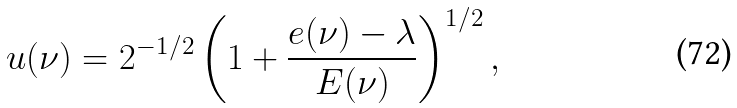<formula> <loc_0><loc_0><loc_500><loc_500>u ( \nu ) = 2 ^ { - 1 / 2 } \left ( 1 + \frac { e ( \nu ) - \lambda } { E ( \nu ) } \right ) ^ { 1 / 2 } ,</formula> 